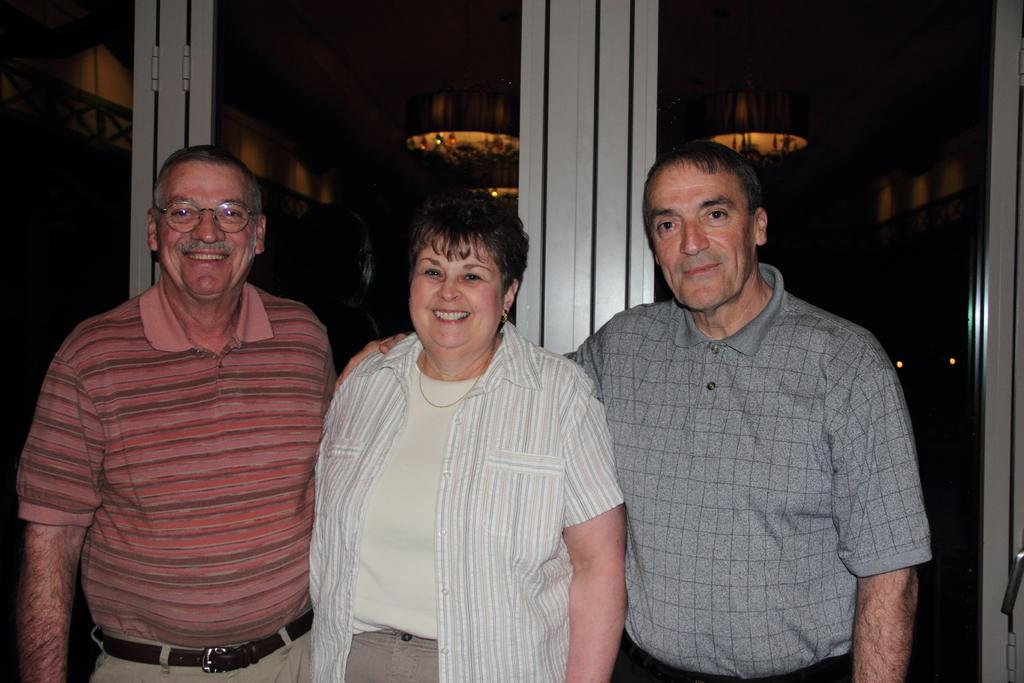How many people are in the image? There are three people standing in the image. What type of door can be seen in the image? There is a glass door visible in the image. Can you describe any objects present in the image? The provided facts do not specify any objects, so we cannot describe them. What is the color of the background in the image? The background of the image is dark. What type of plant is the daughter watering in the image? There is no daughter or plant present in the image. What type of trade is being conducted in the image? There is no trade being conducted in the image. 